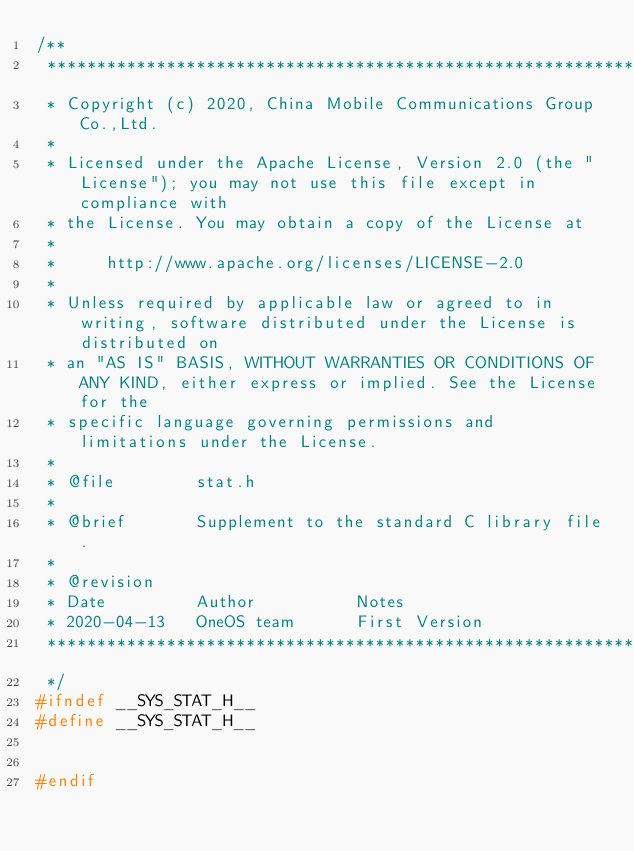<code> <loc_0><loc_0><loc_500><loc_500><_C_>/**
 ***********************************************************************************************************************
 * Copyright (c) 2020, China Mobile Communications Group Co.,Ltd.
 *
 * Licensed under the Apache License, Version 2.0 (the "License"); you may not use this file except in compliance with
 * the License. You may obtain a copy of the License at
 *
 *     http://www.apache.org/licenses/LICENSE-2.0
 *
 * Unless required by applicable law or agreed to in writing, software distributed under the License is distributed on
 * an "AS IS" BASIS, WITHOUT WARRANTIES OR CONDITIONS OF ANY KIND, either express or implied. See the License for the
 * specific language governing permissions and limitations under the License.
 *
 * @file        stat.h
 *
 * @brief       Supplement to the standard C library file.
 *
 * @revision
 * Date         Author          Notes
 * 2020-04-13   OneOS team      First Version
 ***********************************************************************************************************************
 */
#ifndef __SYS_STAT_H__
#define __SYS_STAT_H__


#endif

</code> 